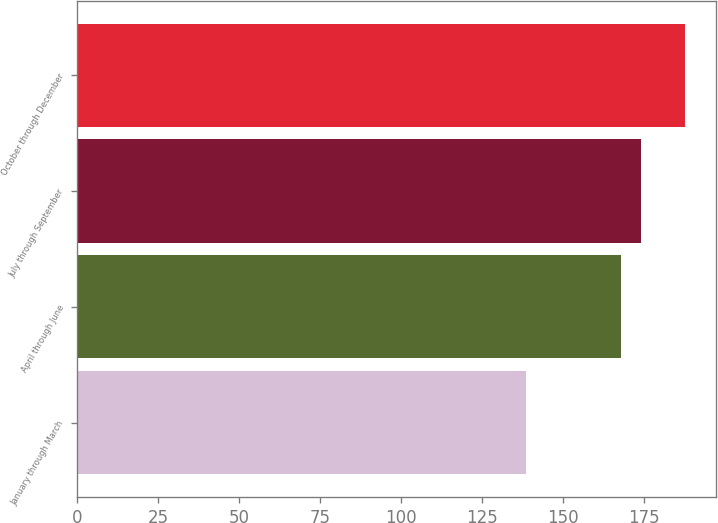Convert chart to OTSL. <chart><loc_0><loc_0><loc_500><loc_500><bar_chart><fcel>January through March<fcel>April through June<fcel>July through September<fcel>October through December<nl><fcel>138.52<fcel>168.03<fcel>174.09<fcel>187.96<nl></chart> 